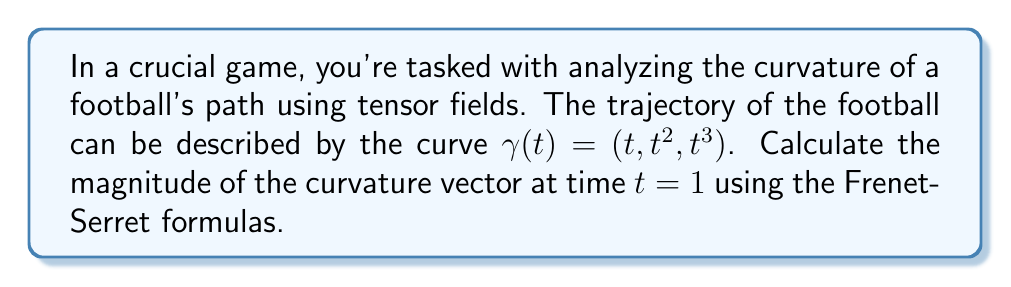Give your solution to this math problem. Let's approach this step-by-step using tensor calculus:

1) First, we need to find the velocity vector $\mathbf{T}(t)$:
   $$\mathbf{T}(t) = \gamma'(t) = (1, 2t, 3t^2)$$

2) At $t=1$, $\mathbf{T}(1) = (1, 2, 3)$

3) Next, we calculate the acceleration vector $\mathbf{T}'(t)$:
   $$\mathbf{T}'(t) = (0, 2, 6t)$$

4) At $t=1$, $\mathbf{T}'(1) = (0, 2, 6)$

5) The curvature vector $\mathbf{\kappa}(t)$ is given by:
   $$\mathbf{\kappa}(t) = \frac{\mathbf{T}'(t) - (\mathbf{T}'(t) \cdot \mathbf{T}(t))\mathbf{T}(t)}{\|\mathbf{T}(t)\|^2}$$

6) We need to calculate $\mathbf{T}'(1) \cdot \mathbf{T}(1)$:
   $$(0, 2, 6) \cdot (1, 2, 3) = 0 + 4 + 18 = 22$$

7) And $\|\mathbf{T}(1)\|^2$:
   $$\|(1, 2, 3)\|^2 = 1^2 + 2^2 + 3^2 = 14$$

8) Now we can calculate $\mathbf{\kappa}(1)$:
   $$\mathbf{\kappa}(1) = \frac{(0, 2, 6) - 22(1, 2, 3)/14}{14}$$
   $$= \frac{(0, 2, 6) - (11/7, 22/7, 33/7)}{14}$$
   $$= \frac{(-11/7, -8/7, 9/7)}{14}$$
   $$= (-11/98, -4/49, 9/98)$$

9) The magnitude of the curvature vector is:
   $$\|\mathbf{\kappa}(1)\| = \sqrt{(-11/98)^2 + (-4/49)^2 + (9/98)^2}$$
   $$= \sqrt{121/9604 + 16/2401 + 81/9604}$$
   $$= \sqrt{(121+324+81)/9604}$$
   $$= \sqrt{526/9604}$$
   $$= \sqrt{263/4802}$$
   $$\approx 0.2343$$
Answer: $\sqrt{263/4802}$ 